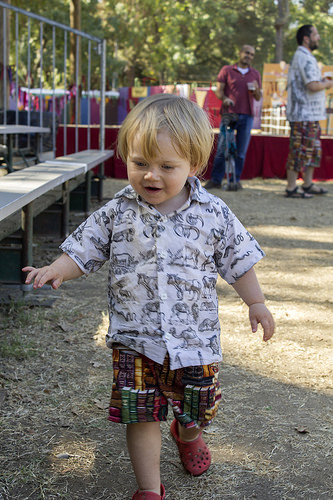<image>
Can you confirm if the child is on the bench? No. The child is not positioned on the bench. They may be near each other, but the child is not supported by or resting on top of the bench. 